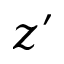<formula> <loc_0><loc_0><loc_500><loc_500>z ^ { \prime }</formula> 